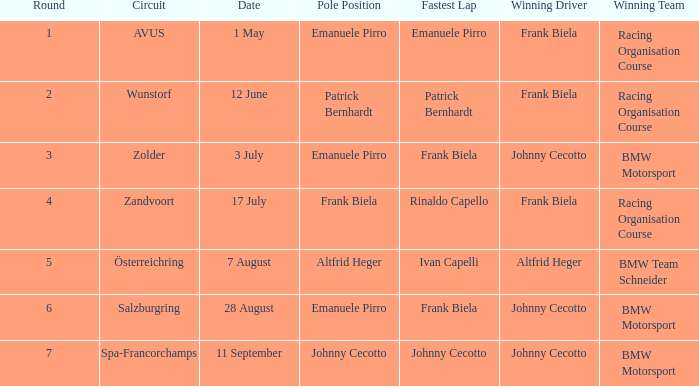Who was the triumphant team at the circuit zolder? BMW Motorsport. 